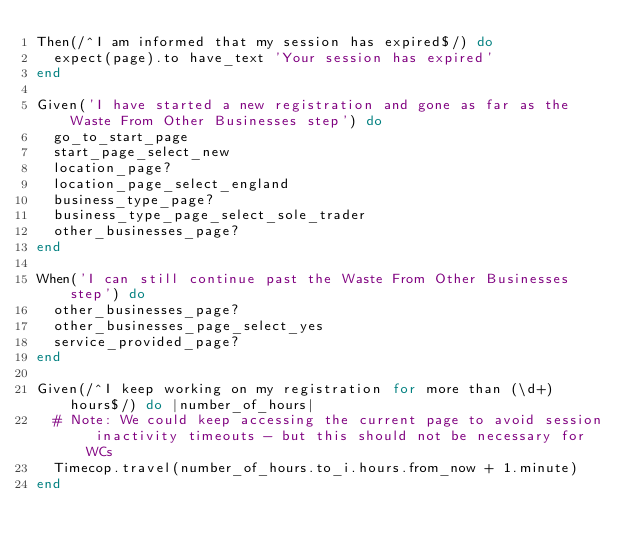Convert code to text. <code><loc_0><loc_0><loc_500><loc_500><_Ruby_>Then(/^I am informed that my session has expired$/) do
  expect(page).to have_text 'Your session has expired'
end

Given('I have started a new registration and gone as far as the Waste From Other Businesses step') do
  go_to_start_page
  start_page_select_new
  location_page?
  location_page_select_england
  business_type_page?
  business_type_page_select_sole_trader
  other_businesses_page?
end

When('I can still continue past the Waste From Other Businesses step') do
  other_businesses_page?
  other_businesses_page_select_yes
  service_provided_page?
end

Given(/^I keep working on my registration for more than (\d+) hours$/) do |number_of_hours|
  # Note: We could keep accessing the current page to avoid session inactivity timeouts - but this should not be necessary for WCs
  Timecop.travel(number_of_hours.to_i.hours.from_now + 1.minute)
end
</code> 